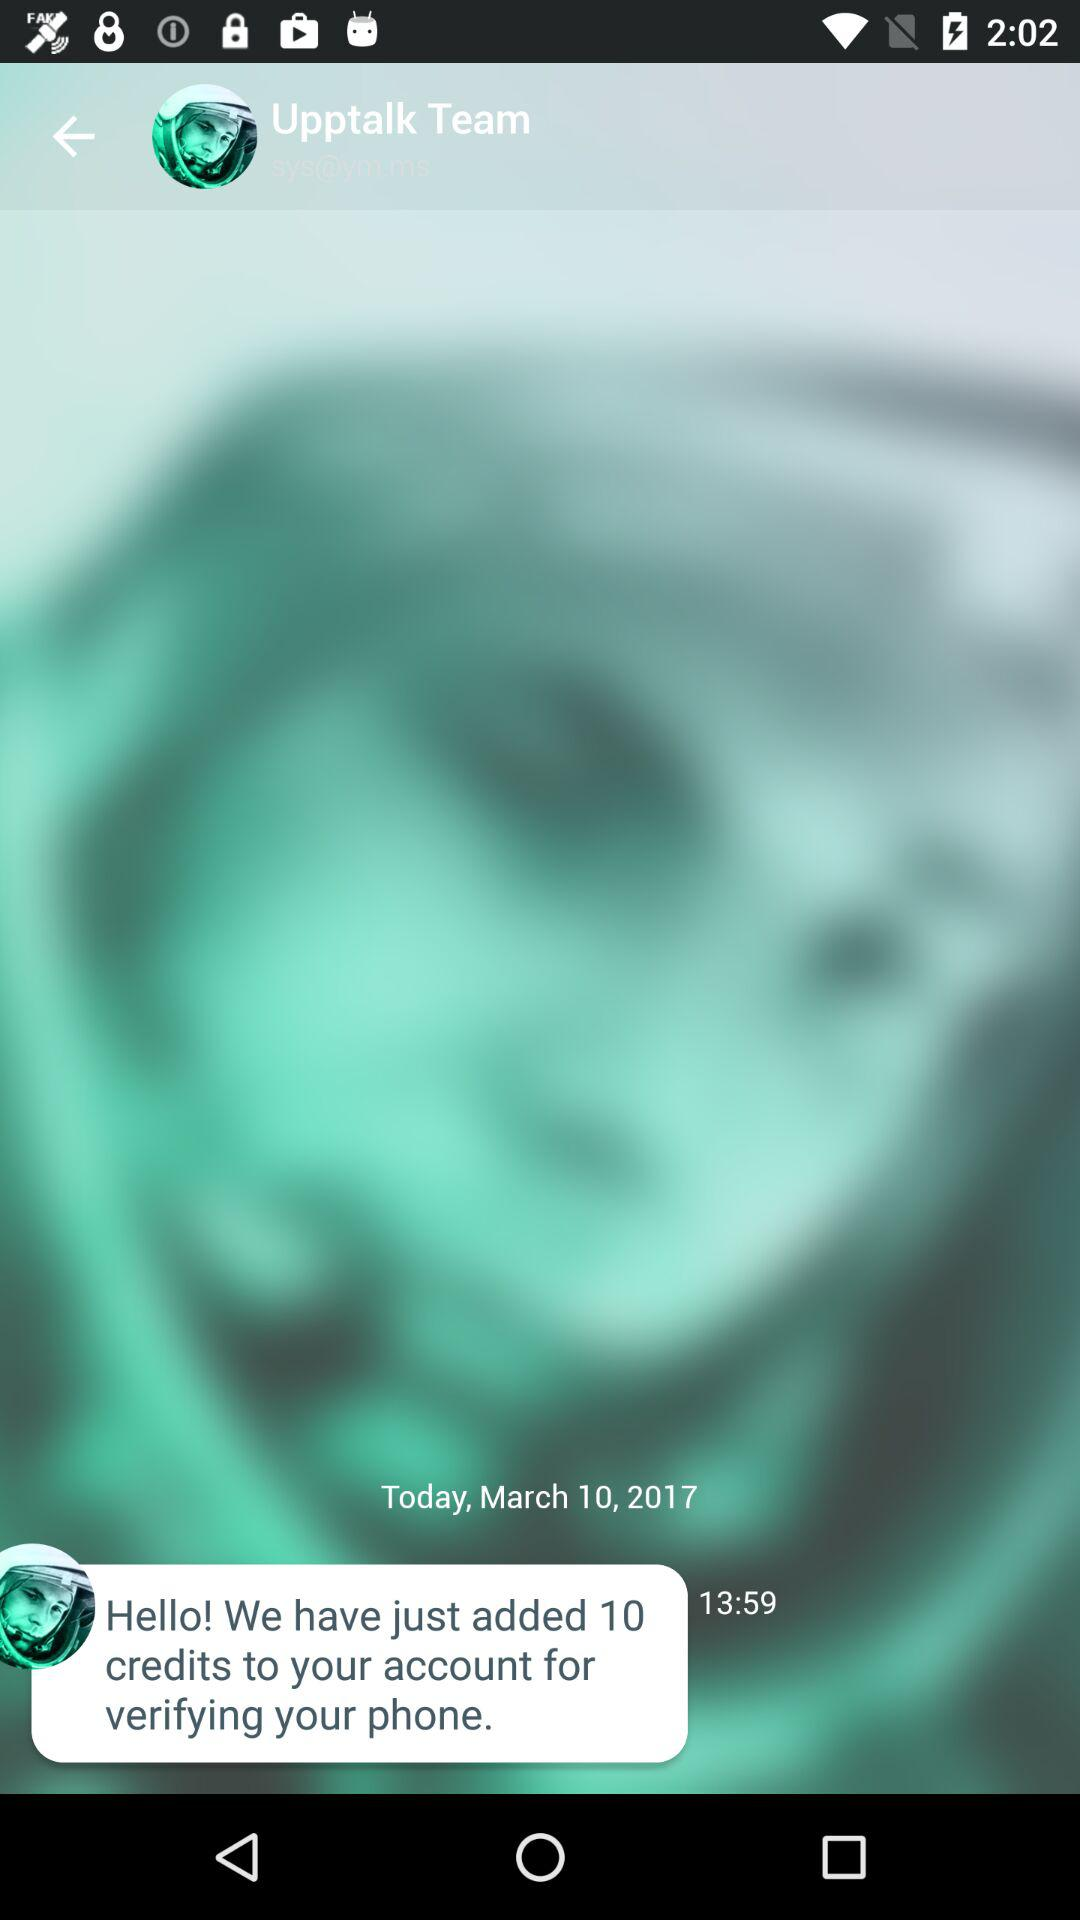By whom was the message sent? The message was sent by the "Upptalk Team". 